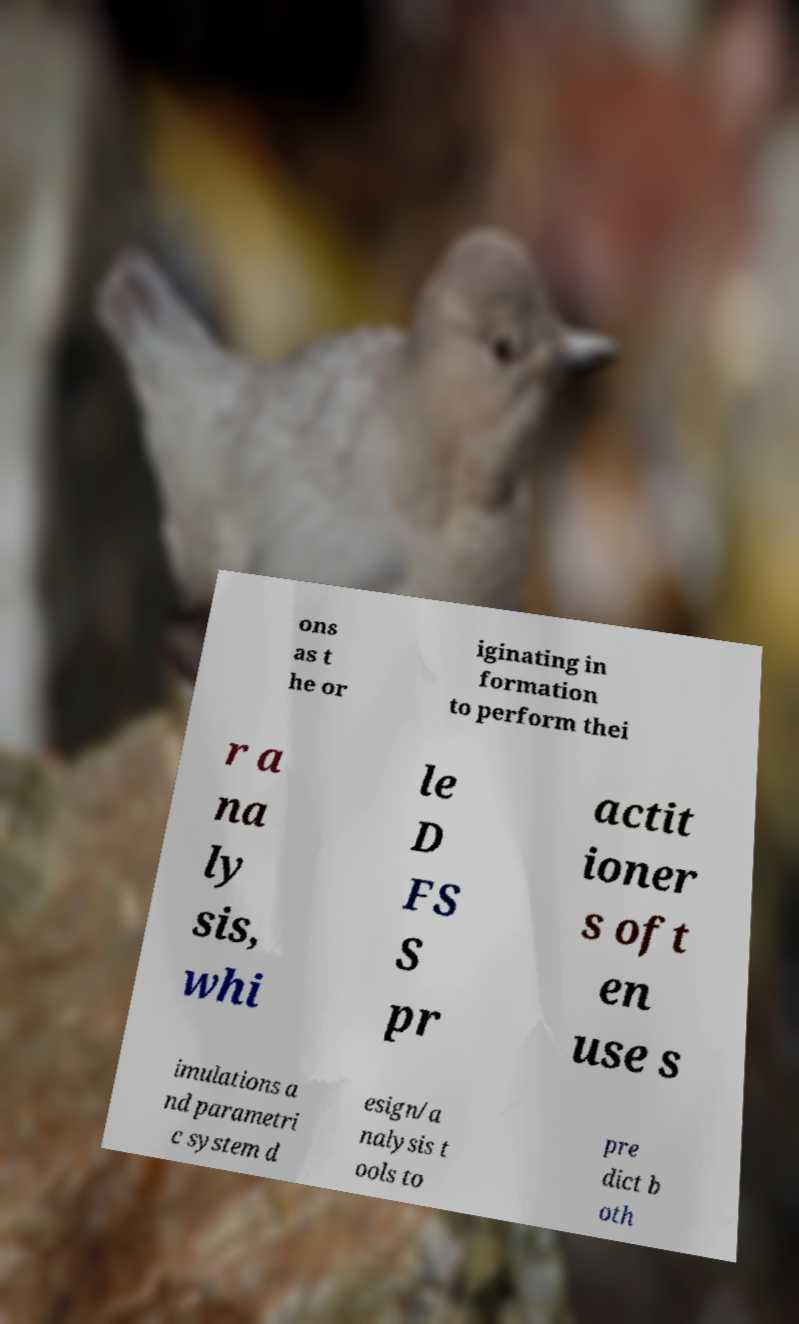For documentation purposes, I need the text within this image transcribed. Could you provide that? ons as t he or iginating in formation to perform thei r a na ly sis, whi le D FS S pr actit ioner s oft en use s imulations a nd parametri c system d esign/a nalysis t ools to pre dict b oth 